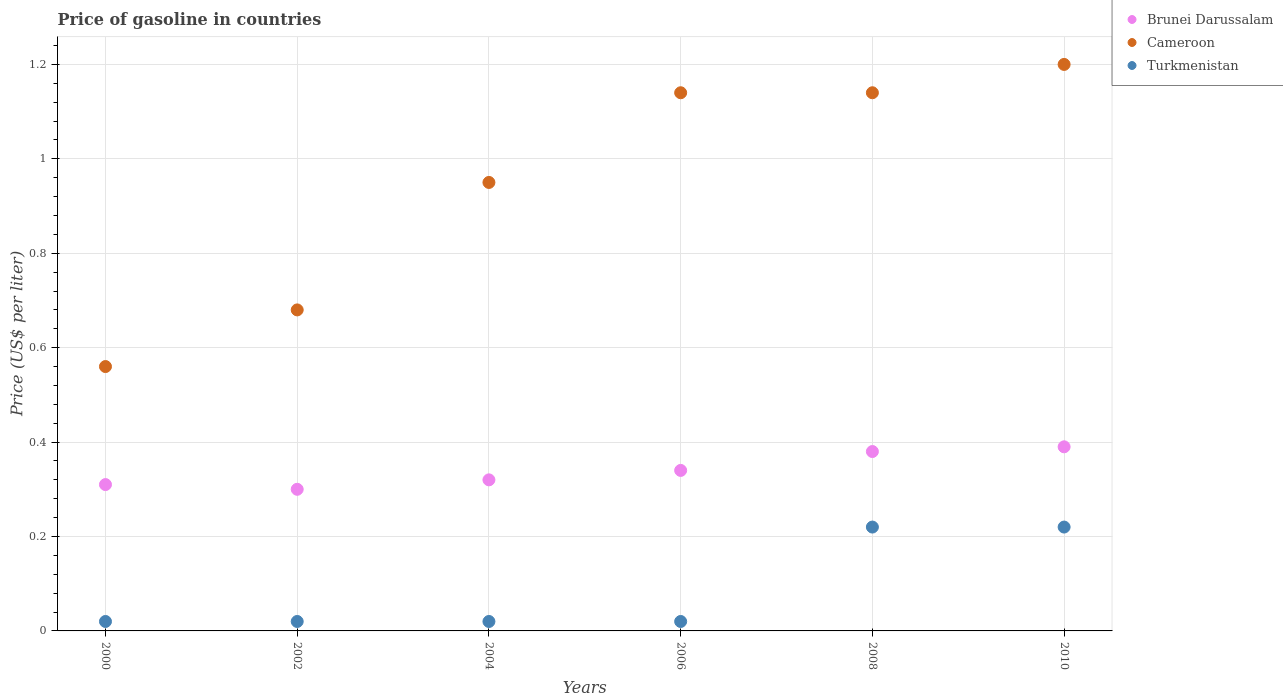Is the number of dotlines equal to the number of legend labels?
Provide a succinct answer. Yes. Across all years, what is the maximum price of gasoline in Turkmenistan?
Ensure brevity in your answer.  0.22. In which year was the price of gasoline in Brunei Darussalam minimum?
Give a very brief answer. 2002. What is the total price of gasoline in Cameroon in the graph?
Offer a very short reply. 5.67. What is the difference between the price of gasoline in Cameroon in 2004 and that in 2008?
Keep it short and to the point. -0.19. What is the difference between the price of gasoline in Turkmenistan in 2004 and the price of gasoline in Brunei Darussalam in 2002?
Your answer should be very brief. -0.28. What is the average price of gasoline in Cameroon per year?
Your response must be concise. 0.94. In the year 2000, what is the difference between the price of gasoline in Brunei Darussalam and price of gasoline in Cameroon?
Your answer should be compact. -0.25. What is the ratio of the price of gasoline in Turkmenistan in 2000 to that in 2008?
Make the answer very short. 0.09. Is the price of gasoline in Brunei Darussalam in 2000 less than that in 2008?
Your response must be concise. Yes. What is the difference between the highest and the second highest price of gasoline in Turkmenistan?
Offer a very short reply. 0. What is the difference between the highest and the lowest price of gasoline in Cameroon?
Your answer should be compact. 0.64. In how many years, is the price of gasoline in Brunei Darussalam greater than the average price of gasoline in Brunei Darussalam taken over all years?
Your answer should be very brief. 2. Is the sum of the price of gasoline in Turkmenistan in 2000 and 2004 greater than the maximum price of gasoline in Cameroon across all years?
Provide a succinct answer. No. Does the price of gasoline in Brunei Darussalam monotonically increase over the years?
Provide a succinct answer. No. How many dotlines are there?
Your response must be concise. 3. What is the difference between two consecutive major ticks on the Y-axis?
Give a very brief answer. 0.2. Are the values on the major ticks of Y-axis written in scientific E-notation?
Provide a succinct answer. No. Where does the legend appear in the graph?
Provide a succinct answer. Top right. How are the legend labels stacked?
Your response must be concise. Vertical. What is the title of the graph?
Your answer should be very brief. Price of gasoline in countries. What is the label or title of the X-axis?
Offer a very short reply. Years. What is the label or title of the Y-axis?
Offer a very short reply. Price (US$ per liter). What is the Price (US$ per liter) of Brunei Darussalam in 2000?
Your answer should be compact. 0.31. What is the Price (US$ per liter) in Cameroon in 2000?
Make the answer very short. 0.56. What is the Price (US$ per liter) in Turkmenistan in 2000?
Your response must be concise. 0.02. What is the Price (US$ per liter) of Cameroon in 2002?
Your answer should be compact. 0.68. What is the Price (US$ per liter) of Brunei Darussalam in 2004?
Provide a succinct answer. 0.32. What is the Price (US$ per liter) of Cameroon in 2004?
Make the answer very short. 0.95. What is the Price (US$ per liter) of Brunei Darussalam in 2006?
Keep it short and to the point. 0.34. What is the Price (US$ per liter) in Cameroon in 2006?
Offer a very short reply. 1.14. What is the Price (US$ per liter) in Brunei Darussalam in 2008?
Your answer should be compact. 0.38. What is the Price (US$ per liter) in Cameroon in 2008?
Your response must be concise. 1.14. What is the Price (US$ per liter) of Turkmenistan in 2008?
Give a very brief answer. 0.22. What is the Price (US$ per liter) in Brunei Darussalam in 2010?
Your answer should be very brief. 0.39. What is the Price (US$ per liter) of Turkmenistan in 2010?
Your answer should be compact. 0.22. Across all years, what is the maximum Price (US$ per liter) in Brunei Darussalam?
Your answer should be compact. 0.39. Across all years, what is the maximum Price (US$ per liter) in Turkmenistan?
Make the answer very short. 0.22. Across all years, what is the minimum Price (US$ per liter) of Cameroon?
Your answer should be very brief. 0.56. What is the total Price (US$ per liter) in Brunei Darussalam in the graph?
Ensure brevity in your answer.  2.04. What is the total Price (US$ per liter) of Cameroon in the graph?
Ensure brevity in your answer.  5.67. What is the total Price (US$ per liter) in Turkmenistan in the graph?
Keep it short and to the point. 0.52. What is the difference between the Price (US$ per liter) in Brunei Darussalam in 2000 and that in 2002?
Make the answer very short. 0.01. What is the difference between the Price (US$ per liter) of Cameroon in 2000 and that in 2002?
Ensure brevity in your answer.  -0.12. What is the difference between the Price (US$ per liter) in Turkmenistan in 2000 and that in 2002?
Provide a short and direct response. 0. What is the difference between the Price (US$ per liter) in Brunei Darussalam in 2000 and that in 2004?
Ensure brevity in your answer.  -0.01. What is the difference between the Price (US$ per liter) of Cameroon in 2000 and that in 2004?
Keep it short and to the point. -0.39. What is the difference between the Price (US$ per liter) of Turkmenistan in 2000 and that in 2004?
Your answer should be compact. 0. What is the difference between the Price (US$ per liter) in Brunei Darussalam in 2000 and that in 2006?
Offer a very short reply. -0.03. What is the difference between the Price (US$ per liter) of Cameroon in 2000 and that in 2006?
Make the answer very short. -0.58. What is the difference between the Price (US$ per liter) in Turkmenistan in 2000 and that in 2006?
Keep it short and to the point. 0. What is the difference between the Price (US$ per liter) in Brunei Darussalam in 2000 and that in 2008?
Your answer should be very brief. -0.07. What is the difference between the Price (US$ per liter) in Cameroon in 2000 and that in 2008?
Give a very brief answer. -0.58. What is the difference between the Price (US$ per liter) of Turkmenistan in 2000 and that in 2008?
Provide a succinct answer. -0.2. What is the difference between the Price (US$ per liter) of Brunei Darussalam in 2000 and that in 2010?
Your response must be concise. -0.08. What is the difference between the Price (US$ per liter) in Cameroon in 2000 and that in 2010?
Ensure brevity in your answer.  -0.64. What is the difference between the Price (US$ per liter) in Brunei Darussalam in 2002 and that in 2004?
Provide a short and direct response. -0.02. What is the difference between the Price (US$ per liter) in Cameroon in 2002 and that in 2004?
Offer a terse response. -0.27. What is the difference between the Price (US$ per liter) in Turkmenistan in 2002 and that in 2004?
Your answer should be very brief. 0. What is the difference between the Price (US$ per liter) in Brunei Darussalam in 2002 and that in 2006?
Offer a very short reply. -0.04. What is the difference between the Price (US$ per liter) of Cameroon in 2002 and that in 2006?
Your response must be concise. -0.46. What is the difference between the Price (US$ per liter) in Brunei Darussalam in 2002 and that in 2008?
Your response must be concise. -0.08. What is the difference between the Price (US$ per liter) in Cameroon in 2002 and that in 2008?
Your response must be concise. -0.46. What is the difference between the Price (US$ per liter) in Turkmenistan in 2002 and that in 2008?
Ensure brevity in your answer.  -0.2. What is the difference between the Price (US$ per liter) of Brunei Darussalam in 2002 and that in 2010?
Make the answer very short. -0.09. What is the difference between the Price (US$ per liter) in Cameroon in 2002 and that in 2010?
Offer a terse response. -0.52. What is the difference between the Price (US$ per liter) of Brunei Darussalam in 2004 and that in 2006?
Provide a succinct answer. -0.02. What is the difference between the Price (US$ per liter) of Cameroon in 2004 and that in 2006?
Provide a succinct answer. -0.19. What is the difference between the Price (US$ per liter) of Turkmenistan in 2004 and that in 2006?
Provide a short and direct response. 0. What is the difference between the Price (US$ per liter) of Brunei Darussalam in 2004 and that in 2008?
Offer a terse response. -0.06. What is the difference between the Price (US$ per liter) in Cameroon in 2004 and that in 2008?
Offer a very short reply. -0.19. What is the difference between the Price (US$ per liter) of Brunei Darussalam in 2004 and that in 2010?
Your answer should be very brief. -0.07. What is the difference between the Price (US$ per liter) in Turkmenistan in 2004 and that in 2010?
Provide a short and direct response. -0.2. What is the difference between the Price (US$ per liter) in Brunei Darussalam in 2006 and that in 2008?
Offer a very short reply. -0.04. What is the difference between the Price (US$ per liter) in Cameroon in 2006 and that in 2008?
Keep it short and to the point. 0. What is the difference between the Price (US$ per liter) in Turkmenistan in 2006 and that in 2008?
Ensure brevity in your answer.  -0.2. What is the difference between the Price (US$ per liter) of Brunei Darussalam in 2006 and that in 2010?
Make the answer very short. -0.05. What is the difference between the Price (US$ per liter) of Cameroon in 2006 and that in 2010?
Your answer should be compact. -0.06. What is the difference between the Price (US$ per liter) of Turkmenistan in 2006 and that in 2010?
Provide a short and direct response. -0.2. What is the difference between the Price (US$ per liter) in Brunei Darussalam in 2008 and that in 2010?
Provide a succinct answer. -0.01. What is the difference between the Price (US$ per liter) of Cameroon in 2008 and that in 2010?
Offer a very short reply. -0.06. What is the difference between the Price (US$ per liter) of Brunei Darussalam in 2000 and the Price (US$ per liter) of Cameroon in 2002?
Your response must be concise. -0.37. What is the difference between the Price (US$ per liter) in Brunei Darussalam in 2000 and the Price (US$ per liter) in Turkmenistan in 2002?
Keep it short and to the point. 0.29. What is the difference between the Price (US$ per liter) of Cameroon in 2000 and the Price (US$ per liter) of Turkmenistan in 2002?
Your answer should be compact. 0.54. What is the difference between the Price (US$ per liter) in Brunei Darussalam in 2000 and the Price (US$ per liter) in Cameroon in 2004?
Your answer should be compact. -0.64. What is the difference between the Price (US$ per liter) in Brunei Darussalam in 2000 and the Price (US$ per liter) in Turkmenistan in 2004?
Offer a very short reply. 0.29. What is the difference between the Price (US$ per liter) of Cameroon in 2000 and the Price (US$ per liter) of Turkmenistan in 2004?
Make the answer very short. 0.54. What is the difference between the Price (US$ per liter) of Brunei Darussalam in 2000 and the Price (US$ per liter) of Cameroon in 2006?
Make the answer very short. -0.83. What is the difference between the Price (US$ per liter) of Brunei Darussalam in 2000 and the Price (US$ per liter) of Turkmenistan in 2006?
Offer a very short reply. 0.29. What is the difference between the Price (US$ per liter) of Cameroon in 2000 and the Price (US$ per liter) of Turkmenistan in 2006?
Your response must be concise. 0.54. What is the difference between the Price (US$ per liter) in Brunei Darussalam in 2000 and the Price (US$ per liter) in Cameroon in 2008?
Ensure brevity in your answer.  -0.83. What is the difference between the Price (US$ per liter) of Brunei Darussalam in 2000 and the Price (US$ per liter) of Turkmenistan in 2008?
Your answer should be very brief. 0.09. What is the difference between the Price (US$ per liter) of Cameroon in 2000 and the Price (US$ per liter) of Turkmenistan in 2008?
Your response must be concise. 0.34. What is the difference between the Price (US$ per liter) of Brunei Darussalam in 2000 and the Price (US$ per liter) of Cameroon in 2010?
Your response must be concise. -0.89. What is the difference between the Price (US$ per liter) in Brunei Darussalam in 2000 and the Price (US$ per liter) in Turkmenistan in 2010?
Provide a succinct answer. 0.09. What is the difference between the Price (US$ per liter) in Cameroon in 2000 and the Price (US$ per liter) in Turkmenistan in 2010?
Your response must be concise. 0.34. What is the difference between the Price (US$ per liter) in Brunei Darussalam in 2002 and the Price (US$ per liter) in Cameroon in 2004?
Ensure brevity in your answer.  -0.65. What is the difference between the Price (US$ per liter) of Brunei Darussalam in 2002 and the Price (US$ per liter) of Turkmenistan in 2004?
Provide a succinct answer. 0.28. What is the difference between the Price (US$ per liter) in Cameroon in 2002 and the Price (US$ per liter) in Turkmenistan in 2004?
Keep it short and to the point. 0.66. What is the difference between the Price (US$ per liter) of Brunei Darussalam in 2002 and the Price (US$ per liter) of Cameroon in 2006?
Make the answer very short. -0.84. What is the difference between the Price (US$ per liter) of Brunei Darussalam in 2002 and the Price (US$ per liter) of Turkmenistan in 2006?
Your response must be concise. 0.28. What is the difference between the Price (US$ per liter) of Cameroon in 2002 and the Price (US$ per liter) of Turkmenistan in 2006?
Your answer should be compact. 0.66. What is the difference between the Price (US$ per liter) of Brunei Darussalam in 2002 and the Price (US$ per liter) of Cameroon in 2008?
Your answer should be compact. -0.84. What is the difference between the Price (US$ per liter) in Brunei Darussalam in 2002 and the Price (US$ per liter) in Turkmenistan in 2008?
Keep it short and to the point. 0.08. What is the difference between the Price (US$ per liter) in Cameroon in 2002 and the Price (US$ per liter) in Turkmenistan in 2008?
Offer a terse response. 0.46. What is the difference between the Price (US$ per liter) in Brunei Darussalam in 2002 and the Price (US$ per liter) in Turkmenistan in 2010?
Make the answer very short. 0.08. What is the difference between the Price (US$ per liter) of Cameroon in 2002 and the Price (US$ per liter) of Turkmenistan in 2010?
Your answer should be compact. 0.46. What is the difference between the Price (US$ per liter) in Brunei Darussalam in 2004 and the Price (US$ per liter) in Cameroon in 2006?
Offer a very short reply. -0.82. What is the difference between the Price (US$ per liter) in Cameroon in 2004 and the Price (US$ per liter) in Turkmenistan in 2006?
Ensure brevity in your answer.  0.93. What is the difference between the Price (US$ per liter) of Brunei Darussalam in 2004 and the Price (US$ per liter) of Cameroon in 2008?
Provide a succinct answer. -0.82. What is the difference between the Price (US$ per liter) in Brunei Darussalam in 2004 and the Price (US$ per liter) in Turkmenistan in 2008?
Provide a short and direct response. 0.1. What is the difference between the Price (US$ per liter) in Cameroon in 2004 and the Price (US$ per liter) in Turkmenistan in 2008?
Offer a terse response. 0.73. What is the difference between the Price (US$ per liter) of Brunei Darussalam in 2004 and the Price (US$ per liter) of Cameroon in 2010?
Ensure brevity in your answer.  -0.88. What is the difference between the Price (US$ per liter) of Brunei Darussalam in 2004 and the Price (US$ per liter) of Turkmenistan in 2010?
Give a very brief answer. 0.1. What is the difference between the Price (US$ per liter) in Cameroon in 2004 and the Price (US$ per liter) in Turkmenistan in 2010?
Make the answer very short. 0.73. What is the difference between the Price (US$ per liter) in Brunei Darussalam in 2006 and the Price (US$ per liter) in Turkmenistan in 2008?
Offer a very short reply. 0.12. What is the difference between the Price (US$ per liter) in Cameroon in 2006 and the Price (US$ per liter) in Turkmenistan in 2008?
Your answer should be compact. 0.92. What is the difference between the Price (US$ per liter) of Brunei Darussalam in 2006 and the Price (US$ per liter) of Cameroon in 2010?
Keep it short and to the point. -0.86. What is the difference between the Price (US$ per liter) in Brunei Darussalam in 2006 and the Price (US$ per liter) in Turkmenistan in 2010?
Your response must be concise. 0.12. What is the difference between the Price (US$ per liter) in Brunei Darussalam in 2008 and the Price (US$ per liter) in Cameroon in 2010?
Provide a succinct answer. -0.82. What is the difference between the Price (US$ per liter) of Brunei Darussalam in 2008 and the Price (US$ per liter) of Turkmenistan in 2010?
Your answer should be very brief. 0.16. What is the difference between the Price (US$ per liter) of Cameroon in 2008 and the Price (US$ per liter) of Turkmenistan in 2010?
Offer a terse response. 0.92. What is the average Price (US$ per liter) in Brunei Darussalam per year?
Offer a very short reply. 0.34. What is the average Price (US$ per liter) of Cameroon per year?
Offer a terse response. 0.94. What is the average Price (US$ per liter) in Turkmenistan per year?
Make the answer very short. 0.09. In the year 2000, what is the difference between the Price (US$ per liter) in Brunei Darussalam and Price (US$ per liter) in Turkmenistan?
Your response must be concise. 0.29. In the year 2000, what is the difference between the Price (US$ per liter) of Cameroon and Price (US$ per liter) of Turkmenistan?
Provide a succinct answer. 0.54. In the year 2002, what is the difference between the Price (US$ per liter) in Brunei Darussalam and Price (US$ per liter) in Cameroon?
Your response must be concise. -0.38. In the year 2002, what is the difference between the Price (US$ per liter) of Brunei Darussalam and Price (US$ per liter) of Turkmenistan?
Provide a succinct answer. 0.28. In the year 2002, what is the difference between the Price (US$ per liter) of Cameroon and Price (US$ per liter) of Turkmenistan?
Keep it short and to the point. 0.66. In the year 2004, what is the difference between the Price (US$ per liter) in Brunei Darussalam and Price (US$ per liter) in Cameroon?
Ensure brevity in your answer.  -0.63. In the year 2006, what is the difference between the Price (US$ per liter) of Brunei Darussalam and Price (US$ per liter) of Turkmenistan?
Make the answer very short. 0.32. In the year 2006, what is the difference between the Price (US$ per liter) of Cameroon and Price (US$ per liter) of Turkmenistan?
Your response must be concise. 1.12. In the year 2008, what is the difference between the Price (US$ per liter) of Brunei Darussalam and Price (US$ per liter) of Cameroon?
Provide a succinct answer. -0.76. In the year 2008, what is the difference between the Price (US$ per liter) of Brunei Darussalam and Price (US$ per liter) of Turkmenistan?
Offer a very short reply. 0.16. In the year 2010, what is the difference between the Price (US$ per liter) in Brunei Darussalam and Price (US$ per liter) in Cameroon?
Make the answer very short. -0.81. In the year 2010, what is the difference between the Price (US$ per liter) in Brunei Darussalam and Price (US$ per liter) in Turkmenistan?
Your answer should be compact. 0.17. What is the ratio of the Price (US$ per liter) of Cameroon in 2000 to that in 2002?
Keep it short and to the point. 0.82. What is the ratio of the Price (US$ per liter) in Turkmenistan in 2000 to that in 2002?
Provide a short and direct response. 1. What is the ratio of the Price (US$ per liter) in Brunei Darussalam in 2000 to that in 2004?
Your response must be concise. 0.97. What is the ratio of the Price (US$ per liter) of Cameroon in 2000 to that in 2004?
Your answer should be compact. 0.59. What is the ratio of the Price (US$ per liter) in Turkmenistan in 2000 to that in 2004?
Your answer should be very brief. 1. What is the ratio of the Price (US$ per liter) in Brunei Darussalam in 2000 to that in 2006?
Keep it short and to the point. 0.91. What is the ratio of the Price (US$ per liter) in Cameroon in 2000 to that in 2006?
Ensure brevity in your answer.  0.49. What is the ratio of the Price (US$ per liter) of Turkmenistan in 2000 to that in 2006?
Your answer should be very brief. 1. What is the ratio of the Price (US$ per liter) in Brunei Darussalam in 2000 to that in 2008?
Make the answer very short. 0.82. What is the ratio of the Price (US$ per liter) in Cameroon in 2000 to that in 2008?
Give a very brief answer. 0.49. What is the ratio of the Price (US$ per liter) in Turkmenistan in 2000 to that in 2008?
Give a very brief answer. 0.09. What is the ratio of the Price (US$ per liter) of Brunei Darussalam in 2000 to that in 2010?
Offer a very short reply. 0.79. What is the ratio of the Price (US$ per liter) of Cameroon in 2000 to that in 2010?
Offer a terse response. 0.47. What is the ratio of the Price (US$ per liter) of Turkmenistan in 2000 to that in 2010?
Provide a short and direct response. 0.09. What is the ratio of the Price (US$ per liter) of Brunei Darussalam in 2002 to that in 2004?
Your answer should be compact. 0.94. What is the ratio of the Price (US$ per liter) of Cameroon in 2002 to that in 2004?
Offer a very short reply. 0.72. What is the ratio of the Price (US$ per liter) in Turkmenistan in 2002 to that in 2004?
Give a very brief answer. 1. What is the ratio of the Price (US$ per liter) of Brunei Darussalam in 2002 to that in 2006?
Your response must be concise. 0.88. What is the ratio of the Price (US$ per liter) in Cameroon in 2002 to that in 2006?
Your answer should be very brief. 0.6. What is the ratio of the Price (US$ per liter) in Turkmenistan in 2002 to that in 2006?
Your answer should be compact. 1. What is the ratio of the Price (US$ per liter) of Brunei Darussalam in 2002 to that in 2008?
Offer a terse response. 0.79. What is the ratio of the Price (US$ per liter) in Cameroon in 2002 to that in 2008?
Keep it short and to the point. 0.6. What is the ratio of the Price (US$ per liter) in Turkmenistan in 2002 to that in 2008?
Your answer should be compact. 0.09. What is the ratio of the Price (US$ per liter) in Brunei Darussalam in 2002 to that in 2010?
Your answer should be very brief. 0.77. What is the ratio of the Price (US$ per liter) of Cameroon in 2002 to that in 2010?
Make the answer very short. 0.57. What is the ratio of the Price (US$ per liter) of Turkmenistan in 2002 to that in 2010?
Offer a very short reply. 0.09. What is the ratio of the Price (US$ per liter) in Turkmenistan in 2004 to that in 2006?
Ensure brevity in your answer.  1. What is the ratio of the Price (US$ per liter) in Brunei Darussalam in 2004 to that in 2008?
Offer a terse response. 0.84. What is the ratio of the Price (US$ per liter) in Turkmenistan in 2004 to that in 2008?
Provide a succinct answer. 0.09. What is the ratio of the Price (US$ per liter) in Brunei Darussalam in 2004 to that in 2010?
Ensure brevity in your answer.  0.82. What is the ratio of the Price (US$ per liter) in Cameroon in 2004 to that in 2010?
Ensure brevity in your answer.  0.79. What is the ratio of the Price (US$ per liter) in Turkmenistan in 2004 to that in 2010?
Keep it short and to the point. 0.09. What is the ratio of the Price (US$ per liter) of Brunei Darussalam in 2006 to that in 2008?
Your response must be concise. 0.89. What is the ratio of the Price (US$ per liter) in Cameroon in 2006 to that in 2008?
Give a very brief answer. 1. What is the ratio of the Price (US$ per liter) in Turkmenistan in 2006 to that in 2008?
Your response must be concise. 0.09. What is the ratio of the Price (US$ per liter) of Brunei Darussalam in 2006 to that in 2010?
Your answer should be compact. 0.87. What is the ratio of the Price (US$ per liter) of Cameroon in 2006 to that in 2010?
Provide a succinct answer. 0.95. What is the ratio of the Price (US$ per liter) in Turkmenistan in 2006 to that in 2010?
Give a very brief answer. 0.09. What is the ratio of the Price (US$ per liter) in Brunei Darussalam in 2008 to that in 2010?
Offer a very short reply. 0.97. What is the ratio of the Price (US$ per liter) of Cameroon in 2008 to that in 2010?
Provide a succinct answer. 0.95. What is the ratio of the Price (US$ per liter) in Turkmenistan in 2008 to that in 2010?
Give a very brief answer. 1. What is the difference between the highest and the second highest Price (US$ per liter) in Brunei Darussalam?
Provide a short and direct response. 0.01. What is the difference between the highest and the second highest Price (US$ per liter) of Turkmenistan?
Keep it short and to the point. 0. What is the difference between the highest and the lowest Price (US$ per liter) of Brunei Darussalam?
Give a very brief answer. 0.09. What is the difference between the highest and the lowest Price (US$ per liter) in Cameroon?
Offer a very short reply. 0.64. What is the difference between the highest and the lowest Price (US$ per liter) in Turkmenistan?
Keep it short and to the point. 0.2. 